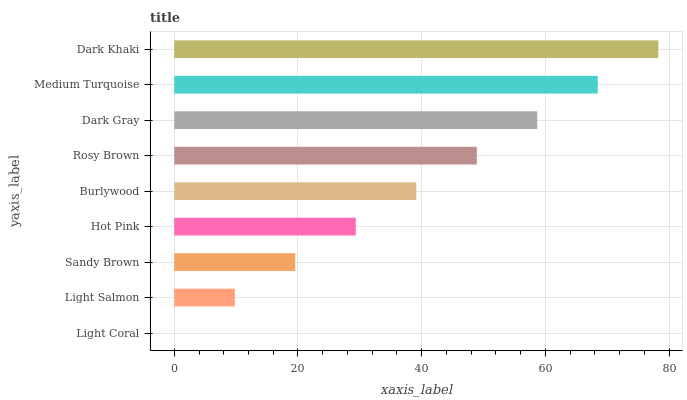Is Light Coral the minimum?
Answer yes or no. Yes. Is Dark Khaki the maximum?
Answer yes or no. Yes. Is Light Salmon the minimum?
Answer yes or no. No. Is Light Salmon the maximum?
Answer yes or no. No. Is Light Salmon greater than Light Coral?
Answer yes or no. Yes. Is Light Coral less than Light Salmon?
Answer yes or no. Yes. Is Light Coral greater than Light Salmon?
Answer yes or no. No. Is Light Salmon less than Light Coral?
Answer yes or no. No. Is Burlywood the high median?
Answer yes or no. Yes. Is Burlywood the low median?
Answer yes or no. Yes. Is Dark Gray the high median?
Answer yes or no. No. Is Hot Pink the low median?
Answer yes or no. No. 